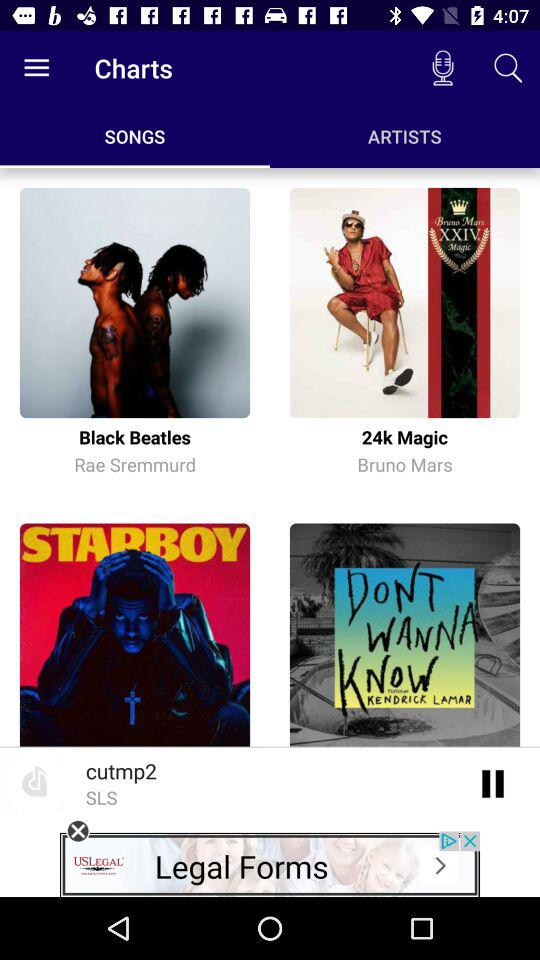Which option is selected for charts? The selected option is "SONGS". 